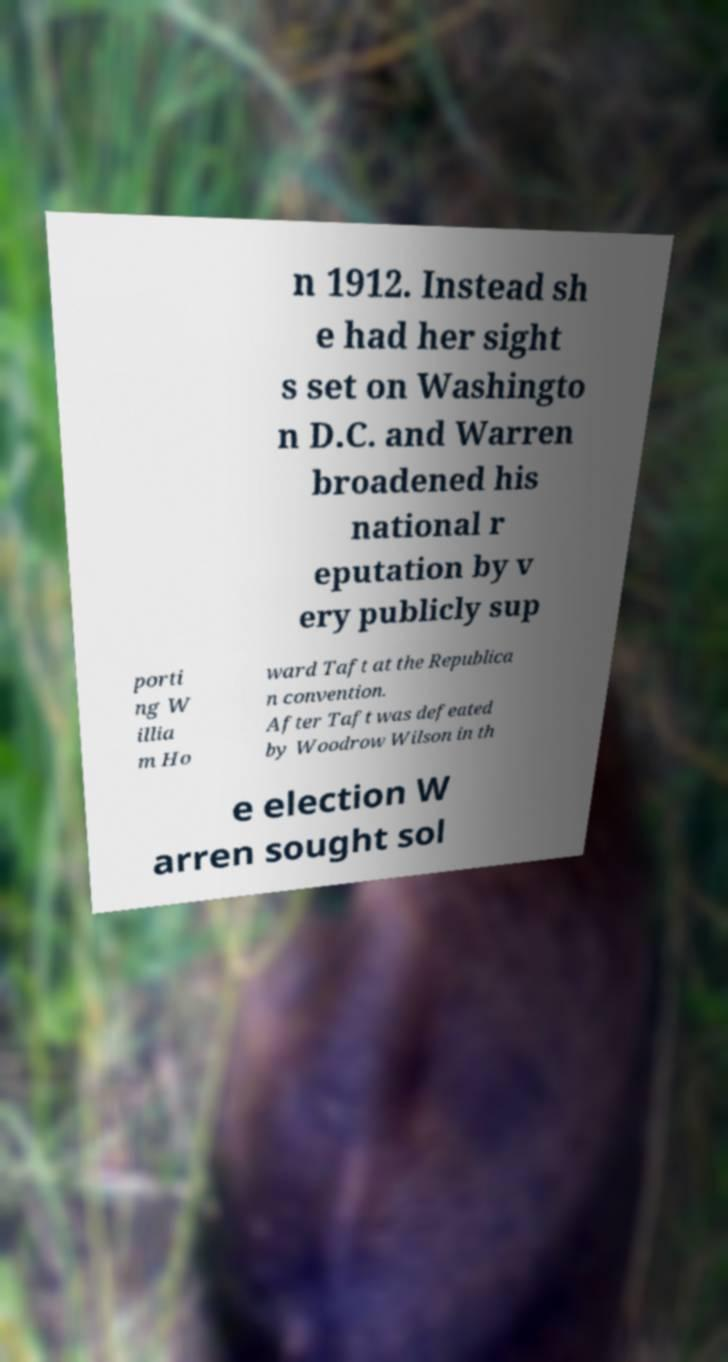For documentation purposes, I need the text within this image transcribed. Could you provide that? n 1912. Instead sh e had her sight s set on Washingto n D.C. and Warren broadened his national r eputation by v ery publicly sup porti ng W illia m Ho ward Taft at the Republica n convention. After Taft was defeated by Woodrow Wilson in th e election W arren sought sol 